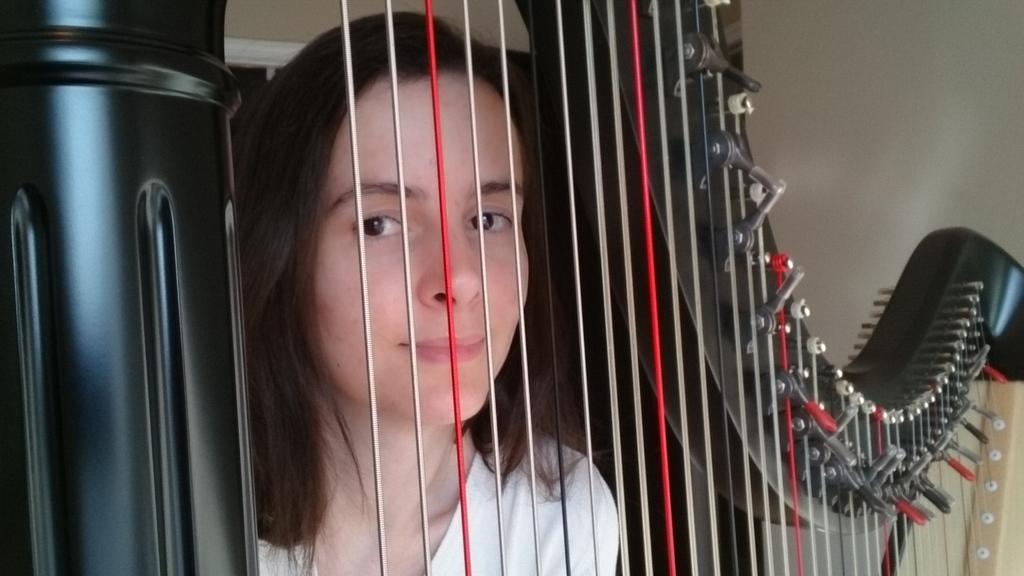What is the main object in the foreground of the image? There is a musical instrument in the foreground of the image. Can you describe the person standing behind the musical instrument? There is a woman standing behind the musical instrument. What type of potato is being used to play the musical instrument in the image? There is no potato present in the image, and the musical instrument is not being played with a potato. 